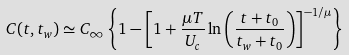Convert formula to latex. <formula><loc_0><loc_0><loc_500><loc_500>C ( t , t _ { w } ) \simeq C _ { \infty } \left \{ 1 - \left [ 1 + \frac { \mu T } { U _ { c } } \ln \left ( \frac { t + t _ { 0 } } { t _ { w } + t _ { 0 } } \right ) \right ] ^ { - 1 / \mu } \right \}</formula> 